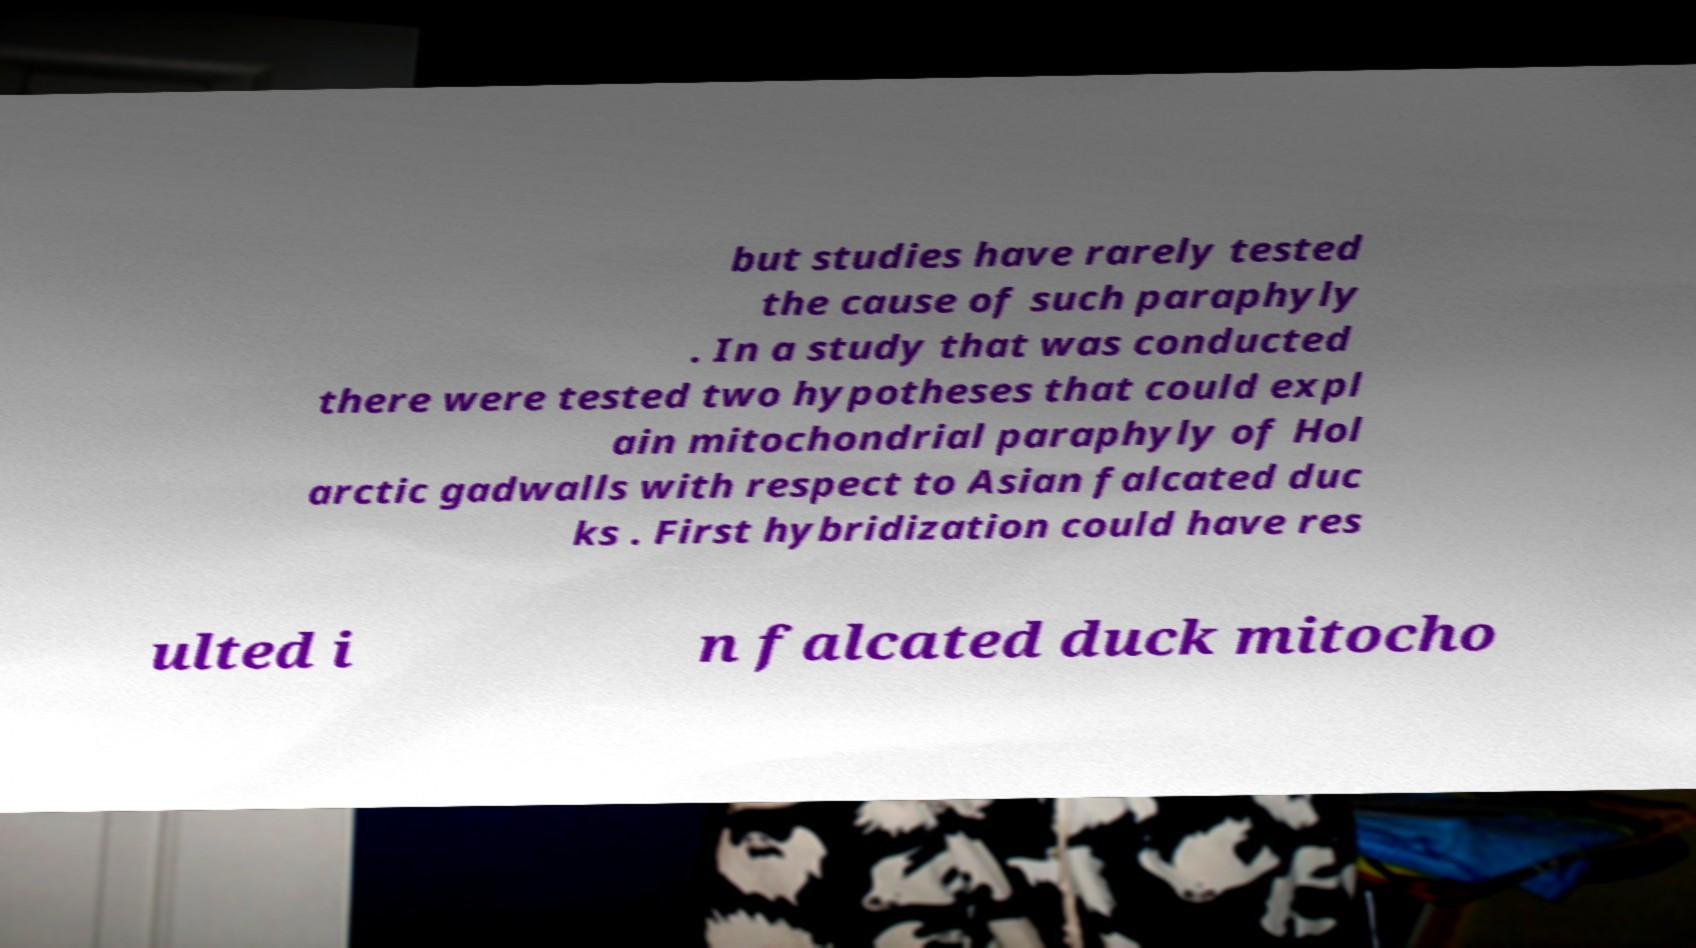Could you extract and type out the text from this image? but studies have rarely tested the cause of such paraphyly . In a study that was conducted there were tested two hypotheses that could expl ain mitochondrial paraphyly of Hol arctic gadwalls with respect to Asian falcated duc ks . First hybridization could have res ulted i n falcated duck mitocho 